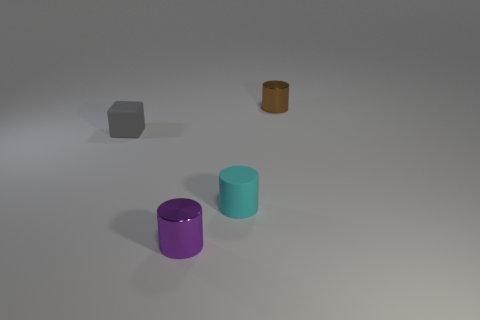How do the sizes of the objects compare to each other? The cyan cylinder is the largest object, followed by the purple cylinder. The cube and the small brown cylinder are the smallest, with the brown cylinder being the tiniest among all. 